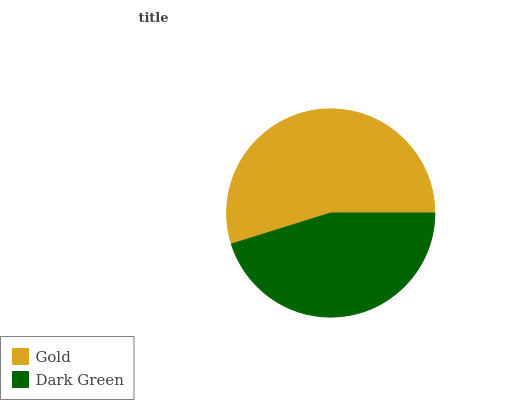Is Dark Green the minimum?
Answer yes or no. Yes. Is Gold the maximum?
Answer yes or no. Yes. Is Dark Green the maximum?
Answer yes or no. No. Is Gold greater than Dark Green?
Answer yes or no. Yes. Is Dark Green less than Gold?
Answer yes or no. Yes. Is Dark Green greater than Gold?
Answer yes or no. No. Is Gold less than Dark Green?
Answer yes or no. No. Is Gold the high median?
Answer yes or no. Yes. Is Dark Green the low median?
Answer yes or no. Yes. Is Dark Green the high median?
Answer yes or no. No. Is Gold the low median?
Answer yes or no. No. 